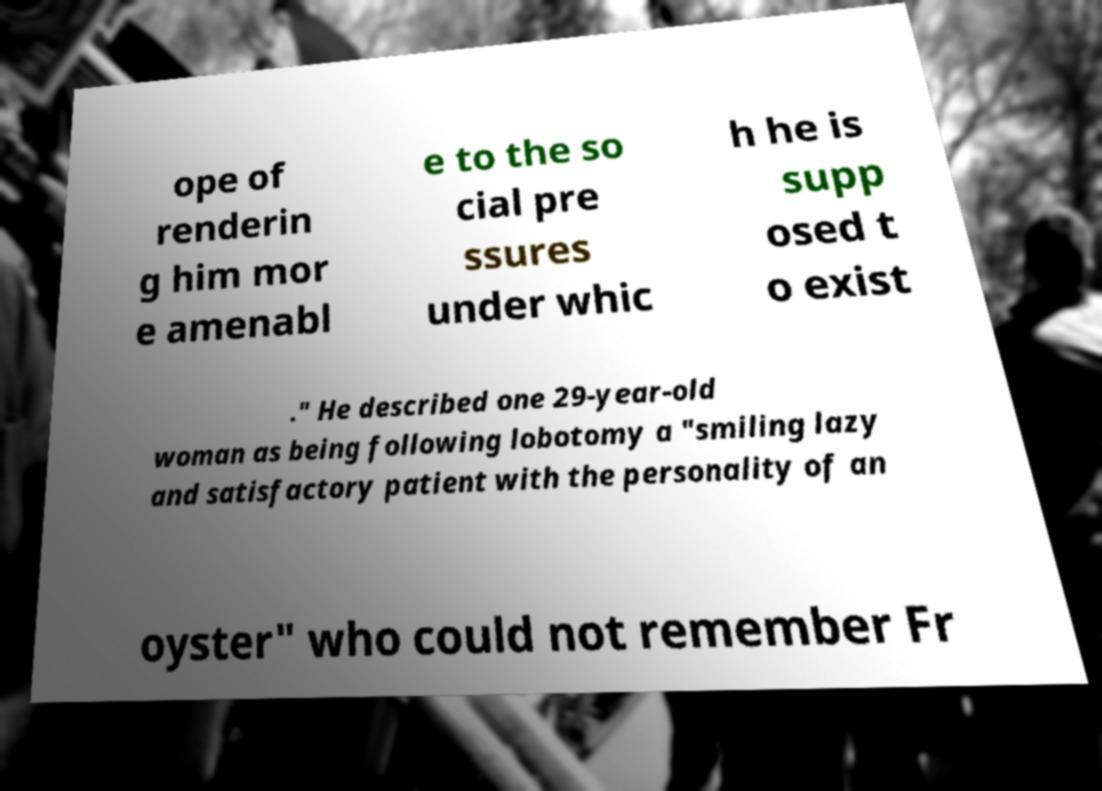For documentation purposes, I need the text within this image transcribed. Could you provide that? ope of renderin g him mor e amenabl e to the so cial pre ssures under whic h he is supp osed t o exist ." He described one 29-year-old woman as being following lobotomy a "smiling lazy and satisfactory patient with the personality of an oyster" who could not remember Fr 